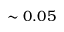Convert formula to latex. <formula><loc_0><loc_0><loc_500><loc_500>\sim 0 . 0 5</formula> 